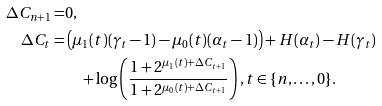<formula> <loc_0><loc_0><loc_500><loc_500>\Delta { C } _ { n + 1 } = & 0 , \\ \Delta { C } _ { t } = & \left ( \mu _ { 1 } ( t ) ( \gamma _ { t } - 1 ) - \mu _ { 0 } ( t ) ( \alpha _ { t } - 1 ) \right ) + H ( \alpha _ { t } ) - H ( \gamma _ { t } ) \\ & \quad + \log \left ( \frac { 1 + 2 ^ { \mu _ { 1 } ( t ) + \Delta { C } _ { t + 1 } } } { 1 + 2 ^ { \mu _ { 0 } ( t ) + \Delta { C } _ { t + 1 } } } \right ) , t \in \{ n , \dots , 0 \} .</formula> 